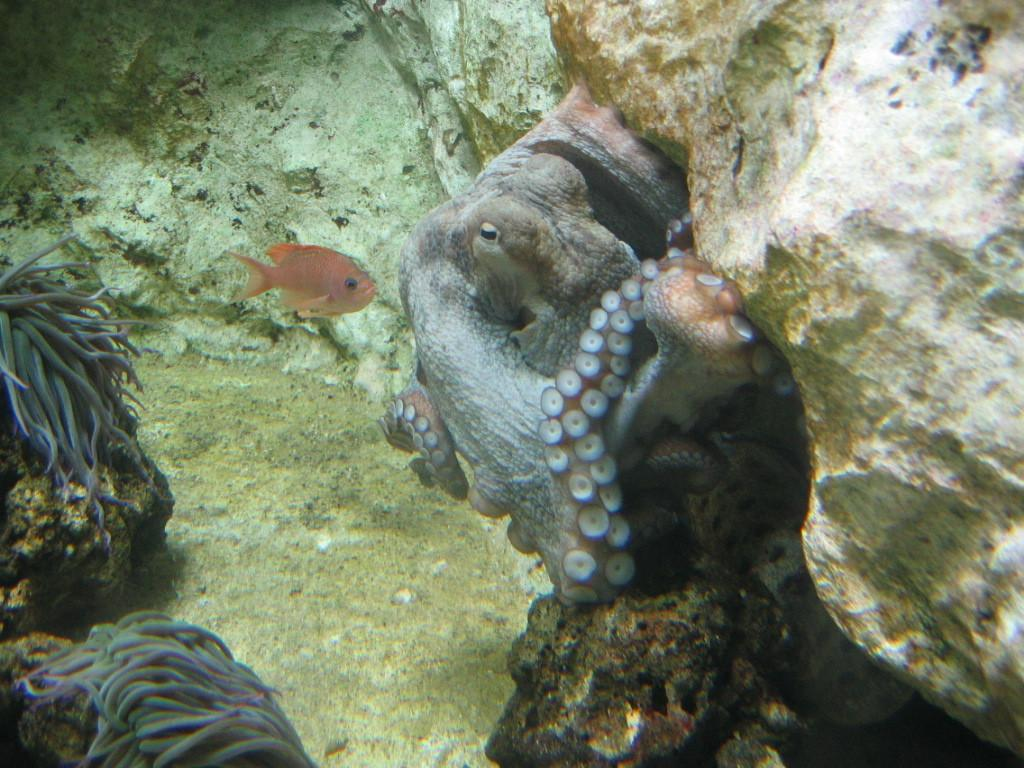What type of animal is present in the image? There is a fish in the image. What other object can be seen on the right side of the image? There is a rock visible on the right side of the image. What else is visible in the middle of the image besides the fish? There are sea animals visible in the middle of the image. What type of kitty can be seen wearing a shirt in the image? There is no kitty or shirt present in the image; it features a fish and sea animals. Can you tell me how many bikes are visible in the image? There are no bikes present in the image. 